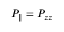<formula> <loc_0><loc_0><loc_500><loc_500>P _ { \| } = P _ { z z }</formula> 